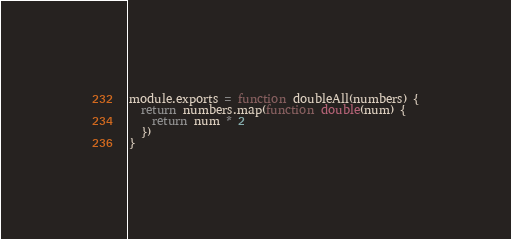Convert code to text. <code><loc_0><loc_0><loc_500><loc_500><_JavaScript_>module.exports = function doubleAll(numbers) {
  return numbers.map(function double(num) {
    return num * 2
  })
}
</code> 